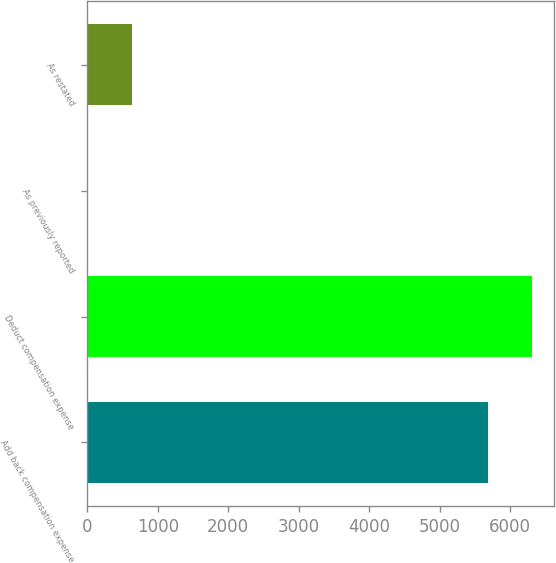<chart> <loc_0><loc_0><loc_500><loc_500><bar_chart><fcel>Add back compensation expense<fcel>Deduct compensation expense<fcel>As previously reported<fcel>As restated<nl><fcel>5686<fcel>6309.94<fcel>10.57<fcel>634.51<nl></chart> 